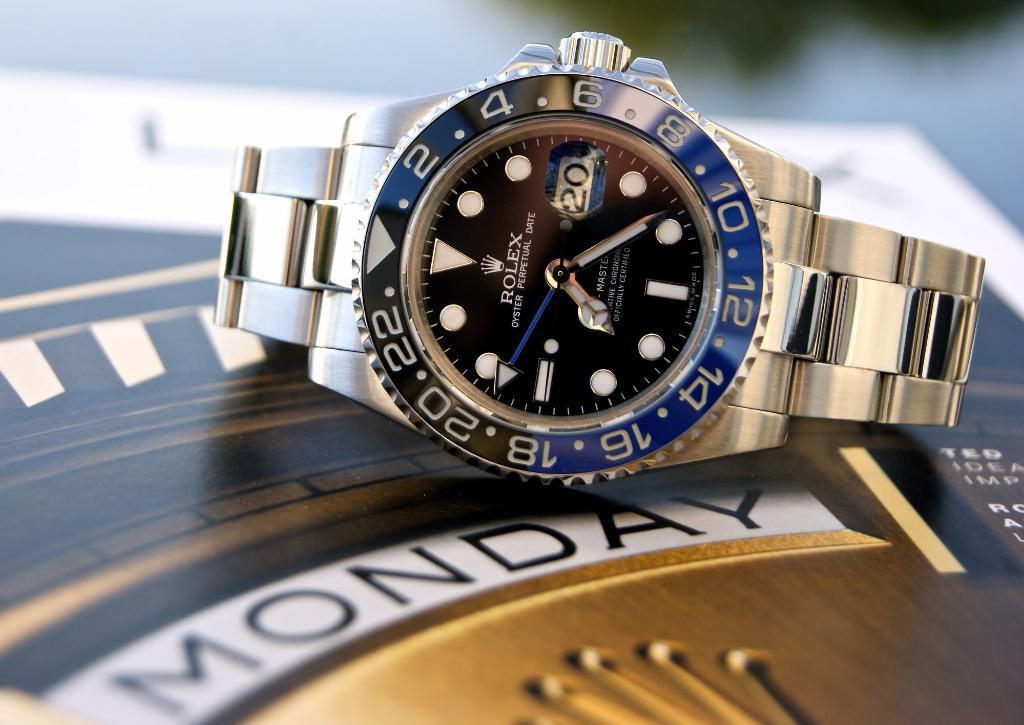Provide a one-sentence caption for the provided image. A gold 24-hour Rolex watch sets on a gold weekly tabletop clock labeled Monday. 